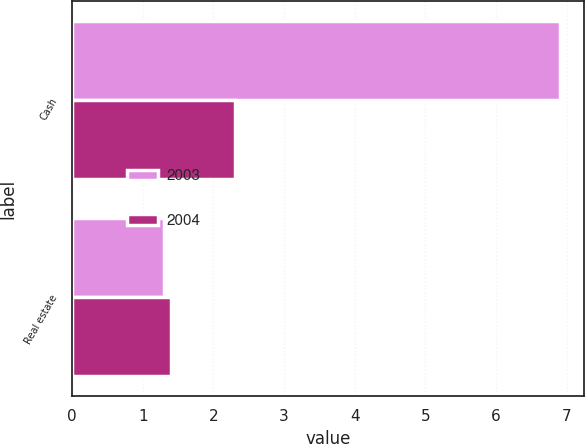Convert chart. <chart><loc_0><loc_0><loc_500><loc_500><stacked_bar_chart><ecel><fcel>Cash<fcel>Real estate<nl><fcel>2003<fcel>6.9<fcel>1.3<nl><fcel>2004<fcel>2.3<fcel>1.4<nl></chart> 